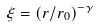Convert formula to latex. <formula><loc_0><loc_0><loc_500><loc_500>\xi = ( r / r _ { 0 } ) ^ { - \gamma }</formula> 